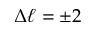Convert formula to latex. <formula><loc_0><loc_0><loc_500><loc_500>\Delta \ell = \pm 2</formula> 